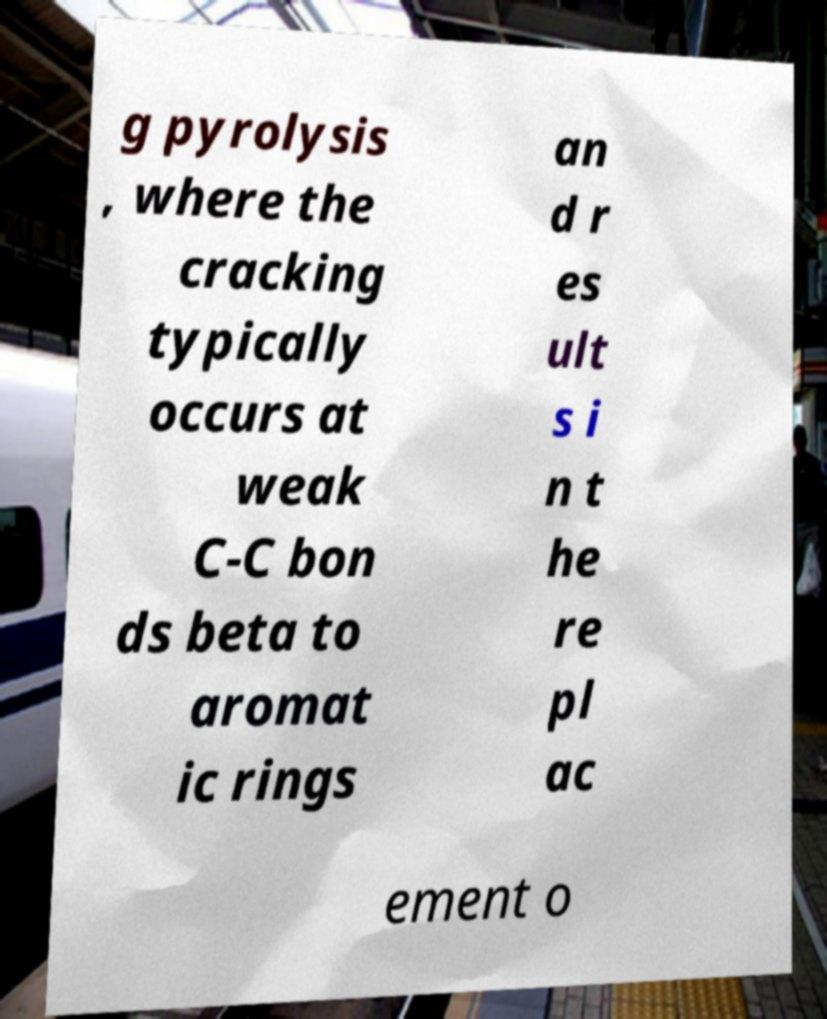Can you accurately transcribe the text from the provided image for me? g pyrolysis , where the cracking typically occurs at weak C-C bon ds beta to aromat ic rings an d r es ult s i n t he re pl ac ement o 